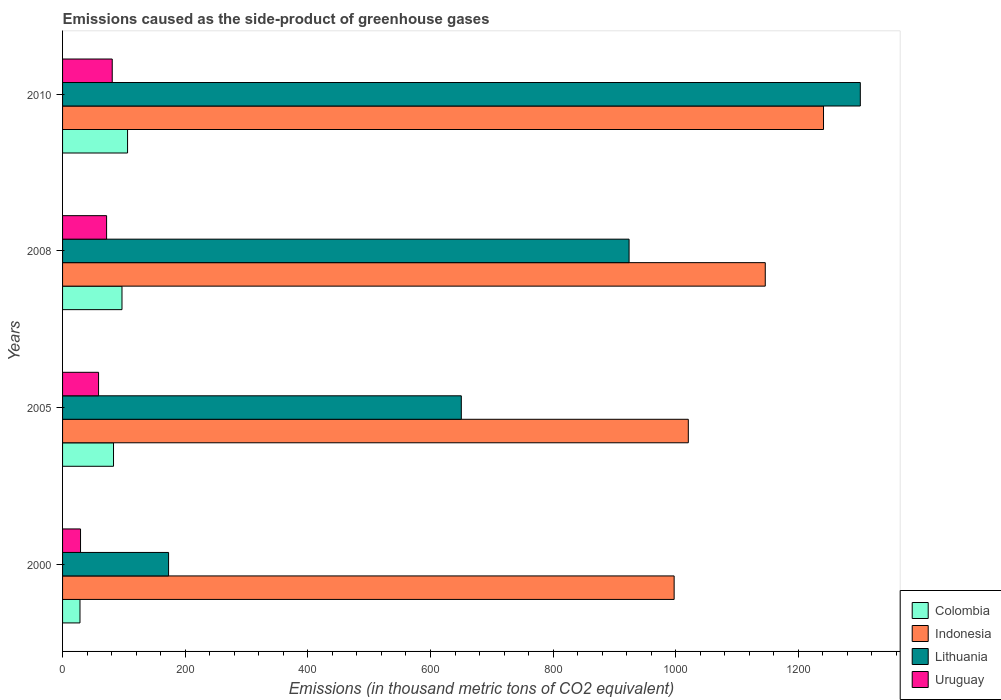How many different coloured bars are there?
Your answer should be very brief. 4. How many groups of bars are there?
Offer a very short reply. 4. Are the number of bars on each tick of the Y-axis equal?
Your answer should be compact. Yes. How many bars are there on the 4th tick from the bottom?
Offer a terse response. 4. What is the emissions caused as the side-product of greenhouse gases in Colombia in 2010?
Keep it short and to the point. 106. Across all years, what is the maximum emissions caused as the side-product of greenhouse gases in Colombia?
Keep it short and to the point. 106. Across all years, what is the minimum emissions caused as the side-product of greenhouse gases in Colombia?
Provide a short and direct response. 28.4. What is the total emissions caused as the side-product of greenhouse gases in Indonesia in the graph?
Your response must be concise. 4404.9. What is the difference between the emissions caused as the side-product of greenhouse gases in Colombia in 2000 and that in 2005?
Your answer should be very brief. -54.7. What is the difference between the emissions caused as the side-product of greenhouse gases in Colombia in 2010 and the emissions caused as the side-product of greenhouse gases in Uruguay in 2005?
Keep it short and to the point. 47.3. What is the average emissions caused as the side-product of greenhouse gases in Uruguay per year?
Give a very brief answer. 60.2. In the year 2008, what is the difference between the emissions caused as the side-product of greenhouse gases in Lithuania and emissions caused as the side-product of greenhouse gases in Uruguay?
Provide a succinct answer. 852.1. What is the ratio of the emissions caused as the side-product of greenhouse gases in Lithuania in 2000 to that in 2010?
Your answer should be compact. 0.13. Is the difference between the emissions caused as the side-product of greenhouse gases in Lithuania in 2000 and 2008 greater than the difference between the emissions caused as the side-product of greenhouse gases in Uruguay in 2000 and 2008?
Offer a terse response. No. What is the difference between the highest and the second highest emissions caused as the side-product of greenhouse gases in Uruguay?
Your response must be concise. 9.2. What is the difference between the highest and the lowest emissions caused as the side-product of greenhouse gases in Uruguay?
Give a very brief answer. 51.7. In how many years, is the emissions caused as the side-product of greenhouse gases in Colombia greater than the average emissions caused as the side-product of greenhouse gases in Colombia taken over all years?
Your answer should be compact. 3. Is the sum of the emissions caused as the side-product of greenhouse gases in Colombia in 2008 and 2010 greater than the maximum emissions caused as the side-product of greenhouse gases in Lithuania across all years?
Ensure brevity in your answer.  No. Is it the case that in every year, the sum of the emissions caused as the side-product of greenhouse gases in Uruguay and emissions caused as the side-product of greenhouse gases in Lithuania is greater than the sum of emissions caused as the side-product of greenhouse gases in Indonesia and emissions caused as the side-product of greenhouse gases in Colombia?
Provide a short and direct response. Yes. What does the 4th bar from the top in 2000 represents?
Offer a very short reply. Colombia. Is it the case that in every year, the sum of the emissions caused as the side-product of greenhouse gases in Uruguay and emissions caused as the side-product of greenhouse gases in Indonesia is greater than the emissions caused as the side-product of greenhouse gases in Lithuania?
Make the answer very short. Yes. How many bars are there?
Your answer should be compact. 16. How many years are there in the graph?
Offer a very short reply. 4. What is the difference between two consecutive major ticks on the X-axis?
Your response must be concise. 200. Are the values on the major ticks of X-axis written in scientific E-notation?
Make the answer very short. No. Does the graph contain any zero values?
Provide a short and direct response. No. Does the graph contain grids?
Keep it short and to the point. No. How many legend labels are there?
Give a very brief answer. 4. How are the legend labels stacked?
Provide a succinct answer. Vertical. What is the title of the graph?
Provide a succinct answer. Emissions caused as the side-product of greenhouse gases. Does "Mauritania" appear as one of the legend labels in the graph?
Provide a short and direct response. No. What is the label or title of the X-axis?
Your response must be concise. Emissions (in thousand metric tons of CO2 equivalent). What is the label or title of the Y-axis?
Offer a terse response. Years. What is the Emissions (in thousand metric tons of CO2 equivalent) of Colombia in 2000?
Your answer should be very brief. 28.4. What is the Emissions (in thousand metric tons of CO2 equivalent) of Indonesia in 2000?
Give a very brief answer. 997.4. What is the Emissions (in thousand metric tons of CO2 equivalent) in Lithuania in 2000?
Your answer should be very brief. 172.9. What is the Emissions (in thousand metric tons of CO2 equivalent) of Uruguay in 2000?
Keep it short and to the point. 29.3. What is the Emissions (in thousand metric tons of CO2 equivalent) in Colombia in 2005?
Give a very brief answer. 83.1. What is the Emissions (in thousand metric tons of CO2 equivalent) of Indonesia in 2005?
Ensure brevity in your answer.  1020.5. What is the Emissions (in thousand metric tons of CO2 equivalent) of Lithuania in 2005?
Your answer should be very brief. 650.3. What is the Emissions (in thousand metric tons of CO2 equivalent) in Uruguay in 2005?
Ensure brevity in your answer.  58.7. What is the Emissions (in thousand metric tons of CO2 equivalent) in Colombia in 2008?
Offer a very short reply. 96.9. What is the Emissions (in thousand metric tons of CO2 equivalent) in Indonesia in 2008?
Offer a terse response. 1146. What is the Emissions (in thousand metric tons of CO2 equivalent) in Lithuania in 2008?
Your response must be concise. 923.9. What is the Emissions (in thousand metric tons of CO2 equivalent) of Uruguay in 2008?
Offer a very short reply. 71.8. What is the Emissions (in thousand metric tons of CO2 equivalent) of Colombia in 2010?
Make the answer very short. 106. What is the Emissions (in thousand metric tons of CO2 equivalent) of Indonesia in 2010?
Offer a terse response. 1241. What is the Emissions (in thousand metric tons of CO2 equivalent) of Lithuania in 2010?
Your response must be concise. 1301. Across all years, what is the maximum Emissions (in thousand metric tons of CO2 equivalent) in Colombia?
Your response must be concise. 106. Across all years, what is the maximum Emissions (in thousand metric tons of CO2 equivalent) of Indonesia?
Offer a terse response. 1241. Across all years, what is the maximum Emissions (in thousand metric tons of CO2 equivalent) in Lithuania?
Provide a short and direct response. 1301. Across all years, what is the maximum Emissions (in thousand metric tons of CO2 equivalent) in Uruguay?
Provide a short and direct response. 81. Across all years, what is the minimum Emissions (in thousand metric tons of CO2 equivalent) of Colombia?
Make the answer very short. 28.4. Across all years, what is the minimum Emissions (in thousand metric tons of CO2 equivalent) in Indonesia?
Your answer should be very brief. 997.4. Across all years, what is the minimum Emissions (in thousand metric tons of CO2 equivalent) in Lithuania?
Ensure brevity in your answer.  172.9. Across all years, what is the minimum Emissions (in thousand metric tons of CO2 equivalent) of Uruguay?
Keep it short and to the point. 29.3. What is the total Emissions (in thousand metric tons of CO2 equivalent) of Colombia in the graph?
Provide a succinct answer. 314.4. What is the total Emissions (in thousand metric tons of CO2 equivalent) of Indonesia in the graph?
Ensure brevity in your answer.  4404.9. What is the total Emissions (in thousand metric tons of CO2 equivalent) in Lithuania in the graph?
Your response must be concise. 3048.1. What is the total Emissions (in thousand metric tons of CO2 equivalent) in Uruguay in the graph?
Offer a terse response. 240.8. What is the difference between the Emissions (in thousand metric tons of CO2 equivalent) of Colombia in 2000 and that in 2005?
Offer a terse response. -54.7. What is the difference between the Emissions (in thousand metric tons of CO2 equivalent) in Indonesia in 2000 and that in 2005?
Your response must be concise. -23.1. What is the difference between the Emissions (in thousand metric tons of CO2 equivalent) in Lithuania in 2000 and that in 2005?
Provide a short and direct response. -477.4. What is the difference between the Emissions (in thousand metric tons of CO2 equivalent) of Uruguay in 2000 and that in 2005?
Your response must be concise. -29.4. What is the difference between the Emissions (in thousand metric tons of CO2 equivalent) of Colombia in 2000 and that in 2008?
Ensure brevity in your answer.  -68.5. What is the difference between the Emissions (in thousand metric tons of CO2 equivalent) of Indonesia in 2000 and that in 2008?
Provide a succinct answer. -148.6. What is the difference between the Emissions (in thousand metric tons of CO2 equivalent) in Lithuania in 2000 and that in 2008?
Your answer should be very brief. -751. What is the difference between the Emissions (in thousand metric tons of CO2 equivalent) of Uruguay in 2000 and that in 2008?
Keep it short and to the point. -42.5. What is the difference between the Emissions (in thousand metric tons of CO2 equivalent) of Colombia in 2000 and that in 2010?
Give a very brief answer. -77.6. What is the difference between the Emissions (in thousand metric tons of CO2 equivalent) in Indonesia in 2000 and that in 2010?
Give a very brief answer. -243.6. What is the difference between the Emissions (in thousand metric tons of CO2 equivalent) in Lithuania in 2000 and that in 2010?
Give a very brief answer. -1128.1. What is the difference between the Emissions (in thousand metric tons of CO2 equivalent) in Uruguay in 2000 and that in 2010?
Your response must be concise. -51.7. What is the difference between the Emissions (in thousand metric tons of CO2 equivalent) in Indonesia in 2005 and that in 2008?
Keep it short and to the point. -125.5. What is the difference between the Emissions (in thousand metric tons of CO2 equivalent) in Lithuania in 2005 and that in 2008?
Your answer should be very brief. -273.6. What is the difference between the Emissions (in thousand metric tons of CO2 equivalent) of Colombia in 2005 and that in 2010?
Your answer should be very brief. -22.9. What is the difference between the Emissions (in thousand metric tons of CO2 equivalent) in Indonesia in 2005 and that in 2010?
Your answer should be very brief. -220.5. What is the difference between the Emissions (in thousand metric tons of CO2 equivalent) in Lithuania in 2005 and that in 2010?
Offer a terse response. -650.7. What is the difference between the Emissions (in thousand metric tons of CO2 equivalent) of Uruguay in 2005 and that in 2010?
Provide a short and direct response. -22.3. What is the difference between the Emissions (in thousand metric tons of CO2 equivalent) of Indonesia in 2008 and that in 2010?
Provide a succinct answer. -95. What is the difference between the Emissions (in thousand metric tons of CO2 equivalent) of Lithuania in 2008 and that in 2010?
Provide a succinct answer. -377.1. What is the difference between the Emissions (in thousand metric tons of CO2 equivalent) in Uruguay in 2008 and that in 2010?
Your answer should be very brief. -9.2. What is the difference between the Emissions (in thousand metric tons of CO2 equivalent) in Colombia in 2000 and the Emissions (in thousand metric tons of CO2 equivalent) in Indonesia in 2005?
Your answer should be compact. -992.1. What is the difference between the Emissions (in thousand metric tons of CO2 equivalent) of Colombia in 2000 and the Emissions (in thousand metric tons of CO2 equivalent) of Lithuania in 2005?
Provide a succinct answer. -621.9. What is the difference between the Emissions (in thousand metric tons of CO2 equivalent) of Colombia in 2000 and the Emissions (in thousand metric tons of CO2 equivalent) of Uruguay in 2005?
Offer a very short reply. -30.3. What is the difference between the Emissions (in thousand metric tons of CO2 equivalent) in Indonesia in 2000 and the Emissions (in thousand metric tons of CO2 equivalent) in Lithuania in 2005?
Offer a terse response. 347.1. What is the difference between the Emissions (in thousand metric tons of CO2 equivalent) of Indonesia in 2000 and the Emissions (in thousand metric tons of CO2 equivalent) of Uruguay in 2005?
Your response must be concise. 938.7. What is the difference between the Emissions (in thousand metric tons of CO2 equivalent) of Lithuania in 2000 and the Emissions (in thousand metric tons of CO2 equivalent) of Uruguay in 2005?
Offer a very short reply. 114.2. What is the difference between the Emissions (in thousand metric tons of CO2 equivalent) of Colombia in 2000 and the Emissions (in thousand metric tons of CO2 equivalent) of Indonesia in 2008?
Offer a terse response. -1117.6. What is the difference between the Emissions (in thousand metric tons of CO2 equivalent) of Colombia in 2000 and the Emissions (in thousand metric tons of CO2 equivalent) of Lithuania in 2008?
Ensure brevity in your answer.  -895.5. What is the difference between the Emissions (in thousand metric tons of CO2 equivalent) in Colombia in 2000 and the Emissions (in thousand metric tons of CO2 equivalent) in Uruguay in 2008?
Keep it short and to the point. -43.4. What is the difference between the Emissions (in thousand metric tons of CO2 equivalent) in Indonesia in 2000 and the Emissions (in thousand metric tons of CO2 equivalent) in Lithuania in 2008?
Your answer should be compact. 73.5. What is the difference between the Emissions (in thousand metric tons of CO2 equivalent) of Indonesia in 2000 and the Emissions (in thousand metric tons of CO2 equivalent) of Uruguay in 2008?
Give a very brief answer. 925.6. What is the difference between the Emissions (in thousand metric tons of CO2 equivalent) of Lithuania in 2000 and the Emissions (in thousand metric tons of CO2 equivalent) of Uruguay in 2008?
Offer a terse response. 101.1. What is the difference between the Emissions (in thousand metric tons of CO2 equivalent) of Colombia in 2000 and the Emissions (in thousand metric tons of CO2 equivalent) of Indonesia in 2010?
Give a very brief answer. -1212.6. What is the difference between the Emissions (in thousand metric tons of CO2 equivalent) of Colombia in 2000 and the Emissions (in thousand metric tons of CO2 equivalent) of Lithuania in 2010?
Keep it short and to the point. -1272.6. What is the difference between the Emissions (in thousand metric tons of CO2 equivalent) in Colombia in 2000 and the Emissions (in thousand metric tons of CO2 equivalent) in Uruguay in 2010?
Give a very brief answer. -52.6. What is the difference between the Emissions (in thousand metric tons of CO2 equivalent) of Indonesia in 2000 and the Emissions (in thousand metric tons of CO2 equivalent) of Lithuania in 2010?
Keep it short and to the point. -303.6. What is the difference between the Emissions (in thousand metric tons of CO2 equivalent) of Indonesia in 2000 and the Emissions (in thousand metric tons of CO2 equivalent) of Uruguay in 2010?
Your answer should be very brief. 916.4. What is the difference between the Emissions (in thousand metric tons of CO2 equivalent) of Lithuania in 2000 and the Emissions (in thousand metric tons of CO2 equivalent) of Uruguay in 2010?
Ensure brevity in your answer.  91.9. What is the difference between the Emissions (in thousand metric tons of CO2 equivalent) in Colombia in 2005 and the Emissions (in thousand metric tons of CO2 equivalent) in Indonesia in 2008?
Keep it short and to the point. -1062.9. What is the difference between the Emissions (in thousand metric tons of CO2 equivalent) of Colombia in 2005 and the Emissions (in thousand metric tons of CO2 equivalent) of Lithuania in 2008?
Give a very brief answer. -840.8. What is the difference between the Emissions (in thousand metric tons of CO2 equivalent) in Colombia in 2005 and the Emissions (in thousand metric tons of CO2 equivalent) in Uruguay in 2008?
Ensure brevity in your answer.  11.3. What is the difference between the Emissions (in thousand metric tons of CO2 equivalent) in Indonesia in 2005 and the Emissions (in thousand metric tons of CO2 equivalent) in Lithuania in 2008?
Provide a succinct answer. 96.6. What is the difference between the Emissions (in thousand metric tons of CO2 equivalent) of Indonesia in 2005 and the Emissions (in thousand metric tons of CO2 equivalent) of Uruguay in 2008?
Make the answer very short. 948.7. What is the difference between the Emissions (in thousand metric tons of CO2 equivalent) of Lithuania in 2005 and the Emissions (in thousand metric tons of CO2 equivalent) of Uruguay in 2008?
Your response must be concise. 578.5. What is the difference between the Emissions (in thousand metric tons of CO2 equivalent) in Colombia in 2005 and the Emissions (in thousand metric tons of CO2 equivalent) in Indonesia in 2010?
Ensure brevity in your answer.  -1157.9. What is the difference between the Emissions (in thousand metric tons of CO2 equivalent) of Colombia in 2005 and the Emissions (in thousand metric tons of CO2 equivalent) of Lithuania in 2010?
Give a very brief answer. -1217.9. What is the difference between the Emissions (in thousand metric tons of CO2 equivalent) in Indonesia in 2005 and the Emissions (in thousand metric tons of CO2 equivalent) in Lithuania in 2010?
Your response must be concise. -280.5. What is the difference between the Emissions (in thousand metric tons of CO2 equivalent) in Indonesia in 2005 and the Emissions (in thousand metric tons of CO2 equivalent) in Uruguay in 2010?
Your answer should be compact. 939.5. What is the difference between the Emissions (in thousand metric tons of CO2 equivalent) of Lithuania in 2005 and the Emissions (in thousand metric tons of CO2 equivalent) of Uruguay in 2010?
Offer a very short reply. 569.3. What is the difference between the Emissions (in thousand metric tons of CO2 equivalent) of Colombia in 2008 and the Emissions (in thousand metric tons of CO2 equivalent) of Indonesia in 2010?
Ensure brevity in your answer.  -1144.1. What is the difference between the Emissions (in thousand metric tons of CO2 equivalent) in Colombia in 2008 and the Emissions (in thousand metric tons of CO2 equivalent) in Lithuania in 2010?
Provide a succinct answer. -1204.1. What is the difference between the Emissions (in thousand metric tons of CO2 equivalent) in Indonesia in 2008 and the Emissions (in thousand metric tons of CO2 equivalent) in Lithuania in 2010?
Give a very brief answer. -155. What is the difference between the Emissions (in thousand metric tons of CO2 equivalent) in Indonesia in 2008 and the Emissions (in thousand metric tons of CO2 equivalent) in Uruguay in 2010?
Ensure brevity in your answer.  1065. What is the difference between the Emissions (in thousand metric tons of CO2 equivalent) of Lithuania in 2008 and the Emissions (in thousand metric tons of CO2 equivalent) of Uruguay in 2010?
Ensure brevity in your answer.  842.9. What is the average Emissions (in thousand metric tons of CO2 equivalent) of Colombia per year?
Provide a short and direct response. 78.6. What is the average Emissions (in thousand metric tons of CO2 equivalent) of Indonesia per year?
Offer a very short reply. 1101.22. What is the average Emissions (in thousand metric tons of CO2 equivalent) in Lithuania per year?
Provide a succinct answer. 762.02. What is the average Emissions (in thousand metric tons of CO2 equivalent) in Uruguay per year?
Offer a very short reply. 60.2. In the year 2000, what is the difference between the Emissions (in thousand metric tons of CO2 equivalent) in Colombia and Emissions (in thousand metric tons of CO2 equivalent) in Indonesia?
Keep it short and to the point. -969. In the year 2000, what is the difference between the Emissions (in thousand metric tons of CO2 equivalent) of Colombia and Emissions (in thousand metric tons of CO2 equivalent) of Lithuania?
Your response must be concise. -144.5. In the year 2000, what is the difference between the Emissions (in thousand metric tons of CO2 equivalent) in Indonesia and Emissions (in thousand metric tons of CO2 equivalent) in Lithuania?
Provide a short and direct response. 824.5. In the year 2000, what is the difference between the Emissions (in thousand metric tons of CO2 equivalent) of Indonesia and Emissions (in thousand metric tons of CO2 equivalent) of Uruguay?
Offer a terse response. 968.1. In the year 2000, what is the difference between the Emissions (in thousand metric tons of CO2 equivalent) of Lithuania and Emissions (in thousand metric tons of CO2 equivalent) of Uruguay?
Make the answer very short. 143.6. In the year 2005, what is the difference between the Emissions (in thousand metric tons of CO2 equivalent) in Colombia and Emissions (in thousand metric tons of CO2 equivalent) in Indonesia?
Your answer should be very brief. -937.4. In the year 2005, what is the difference between the Emissions (in thousand metric tons of CO2 equivalent) in Colombia and Emissions (in thousand metric tons of CO2 equivalent) in Lithuania?
Your answer should be compact. -567.2. In the year 2005, what is the difference between the Emissions (in thousand metric tons of CO2 equivalent) of Colombia and Emissions (in thousand metric tons of CO2 equivalent) of Uruguay?
Ensure brevity in your answer.  24.4. In the year 2005, what is the difference between the Emissions (in thousand metric tons of CO2 equivalent) in Indonesia and Emissions (in thousand metric tons of CO2 equivalent) in Lithuania?
Your answer should be very brief. 370.2. In the year 2005, what is the difference between the Emissions (in thousand metric tons of CO2 equivalent) of Indonesia and Emissions (in thousand metric tons of CO2 equivalent) of Uruguay?
Ensure brevity in your answer.  961.8. In the year 2005, what is the difference between the Emissions (in thousand metric tons of CO2 equivalent) in Lithuania and Emissions (in thousand metric tons of CO2 equivalent) in Uruguay?
Provide a short and direct response. 591.6. In the year 2008, what is the difference between the Emissions (in thousand metric tons of CO2 equivalent) in Colombia and Emissions (in thousand metric tons of CO2 equivalent) in Indonesia?
Make the answer very short. -1049.1. In the year 2008, what is the difference between the Emissions (in thousand metric tons of CO2 equivalent) in Colombia and Emissions (in thousand metric tons of CO2 equivalent) in Lithuania?
Offer a very short reply. -827. In the year 2008, what is the difference between the Emissions (in thousand metric tons of CO2 equivalent) in Colombia and Emissions (in thousand metric tons of CO2 equivalent) in Uruguay?
Your response must be concise. 25.1. In the year 2008, what is the difference between the Emissions (in thousand metric tons of CO2 equivalent) of Indonesia and Emissions (in thousand metric tons of CO2 equivalent) of Lithuania?
Make the answer very short. 222.1. In the year 2008, what is the difference between the Emissions (in thousand metric tons of CO2 equivalent) in Indonesia and Emissions (in thousand metric tons of CO2 equivalent) in Uruguay?
Provide a succinct answer. 1074.2. In the year 2008, what is the difference between the Emissions (in thousand metric tons of CO2 equivalent) in Lithuania and Emissions (in thousand metric tons of CO2 equivalent) in Uruguay?
Offer a terse response. 852.1. In the year 2010, what is the difference between the Emissions (in thousand metric tons of CO2 equivalent) of Colombia and Emissions (in thousand metric tons of CO2 equivalent) of Indonesia?
Make the answer very short. -1135. In the year 2010, what is the difference between the Emissions (in thousand metric tons of CO2 equivalent) of Colombia and Emissions (in thousand metric tons of CO2 equivalent) of Lithuania?
Give a very brief answer. -1195. In the year 2010, what is the difference between the Emissions (in thousand metric tons of CO2 equivalent) of Colombia and Emissions (in thousand metric tons of CO2 equivalent) of Uruguay?
Provide a short and direct response. 25. In the year 2010, what is the difference between the Emissions (in thousand metric tons of CO2 equivalent) of Indonesia and Emissions (in thousand metric tons of CO2 equivalent) of Lithuania?
Make the answer very short. -60. In the year 2010, what is the difference between the Emissions (in thousand metric tons of CO2 equivalent) in Indonesia and Emissions (in thousand metric tons of CO2 equivalent) in Uruguay?
Your answer should be compact. 1160. In the year 2010, what is the difference between the Emissions (in thousand metric tons of CO2 equivalent) of Lithuania and Emissions (in thousand metric tons of CO2 equivalent) of Uruguay?
Give a very brief answer. 1220. What is the ratio of the Emissions (in thousand metric tons of CO2 equivalent) of Colombia in 2000 to that in 2005?
Offer a very short reply. 0.34. What is the ratio of the Emissions (in thousand metric tons of CO2 equivalent) in Indonesia in 2000 to that in 2005?
Provide a succinct answer. 0.98. What is the ratio of the Emissions (in thousand metric tons of CO2 equivalent) of Lithuania in 2000 to that in 2005?
Your answer should be compact. 0.27. What is the ratio of the Emissions (in thousand metric tons of CO2 equivalent) in Uruguay in 2000 to that in 2005?
Offer a terse response. 0.5. What is the ratio of the Emissions (in thousand metric tons of CO2 equivalent) in Colombia in 2000 to that in 2008?
Provide a succinct answer. 0.29. What is the ratio of the Emissions (in thousand metric tons of CO2 equivalent) in Indonesia in 2000 to that in 2008?
Your answer should be compact. 0.87. What is the ratio of the Emissions (in thousand metric tons of CO2 equivalent) in Lithuania in 2000 to that in 2008?
Your answer should be very brief. 0.19. What is the ratio of the Emissions (in thousand metric tons of CO2 equivalent) of Uruguay in 2000 to that in 2008?
Your answer should be very brief. 0.41. What is the ratio of the Emissions (in thousand metric tons of CO2 equivalent) in Colombia in 2000 to that in 2010?
Your answer should be very brief. 0.27. What is the ratio of the Emissions (in thousand metric tons of CO2 equivalent) of Indonesia in 2000 to that in 2010?
Keep it short and to the point. 0.8. What is the ratio of the Emissions (in thousand metric tons of CO2 equivalent) of Lithuania in 2000 to that in 2010?
Offer a very short reply. 0.13. What is the ratio of the Emissions (in thousand metric tons of CO2 equivalent) of Uruguay in 2000 to that in 2010?
Ensure brevity in your answer.  0.36. What is the ratio of the Emissions (in thousand metric tons of CO2 equivalent) of Colombia in 2005 to that in 2008?
Provide a succinct answer. 0.86. What is the ratio of the Emissions (in thousand metric tons of CO2 equivalent) in Indonesia in 2005 to that in 2008?
Make the answer very short. 0.89. What is the ratio of the Emissions (in thousand metric tons of CO2 equivalent) in Lithuania in 2005 to that in 2008?
Give a very brief answer. 0.7. What is the ratio of the Emissions (in thousand metric tons of CO2 equivalent) of Uruguay in 2005 to that in 2008?
Your answer should be very brief. 0.82. What is the ratio of the Emissions (in thousand metric tons of CO2 equivalent) in Colombia in 2005 to that in 2010?
Your answer should be compact. 0.78. What is the ratio of the Emissions (in thousand metric tons of CO2 equivalent) of Indonesia in 2005 to that in 2010?
Your answer should be very brief. 0.82. What is the ratio of the Emissions (in thousand metric tons of CO2 equivalent) of Lithuania in 2005 to that in 2010?
Your answer should be very brief. 0.5. What is the ratio of the Emissions (in thousand metric tons of CO2 equivalent) of Uruguay in 2005 to that in 2010?
Provide a short and direct response. 0.72. What is the ratio of the Emissions (in thousand metric tons of CO2 equivalent) in Colombia in 2008 to that in 2010?
Provide a succinct answer. 0.91. What is the ratio of the Emissions (in thousand metric tons of CO2 equivalent) of Indonesia in 2008 to that in 2010?
Keep it short and to the point. 0.92. What is the ratio of the Emissions (in thousand metric tons of CO2 equivalent) of Lithuania in 2008 to that in 2010?
Provide a short and direct response. 0.71. What is the ratio of the Emissions (in thousand metric tons of CO2 equivalent) in Uruguay in 2008 to that in 2010?
Provide a succinct answer. 0.89. What is the difference between the highest and the second highest Emissions (in thousand metric tons of CO2 equivalent) in Colombia?
Offer a very short reply. 9.1. What is the difference between the highest and the second highest Emissions (in thousand metric tons of CO2 equivalent) in Lithuania?
Offer a very short reply. 377.1. What is the difference between the highest and the second highest Emissions (in thousand metric tons of CO2 equivalent) in Uruguay?
Ensure brevity in your answer.  9.2. What is the difference between the highest and the lowest Emissions (in thousand metric tons of CO2 equivalent) of Colombia?
Keep it short and to the point. 77.6. What is the difference between the highest and the lowest Emissions (in thousand metric tons of CO2 equivalent) of Indonesia?
Provide a short and direct response. 243.6. What is the difference between the highest and the lowest Emissions (in thousand metric tons of CO2 equivalent) of Lithuania?
Provide a short and direct response. 1128.1. What is the difference between the highest and the lowest Emissions (in thousand metric tons of CO2 equivalent) of Uruguay?
Offer a terse response. 51.7. 